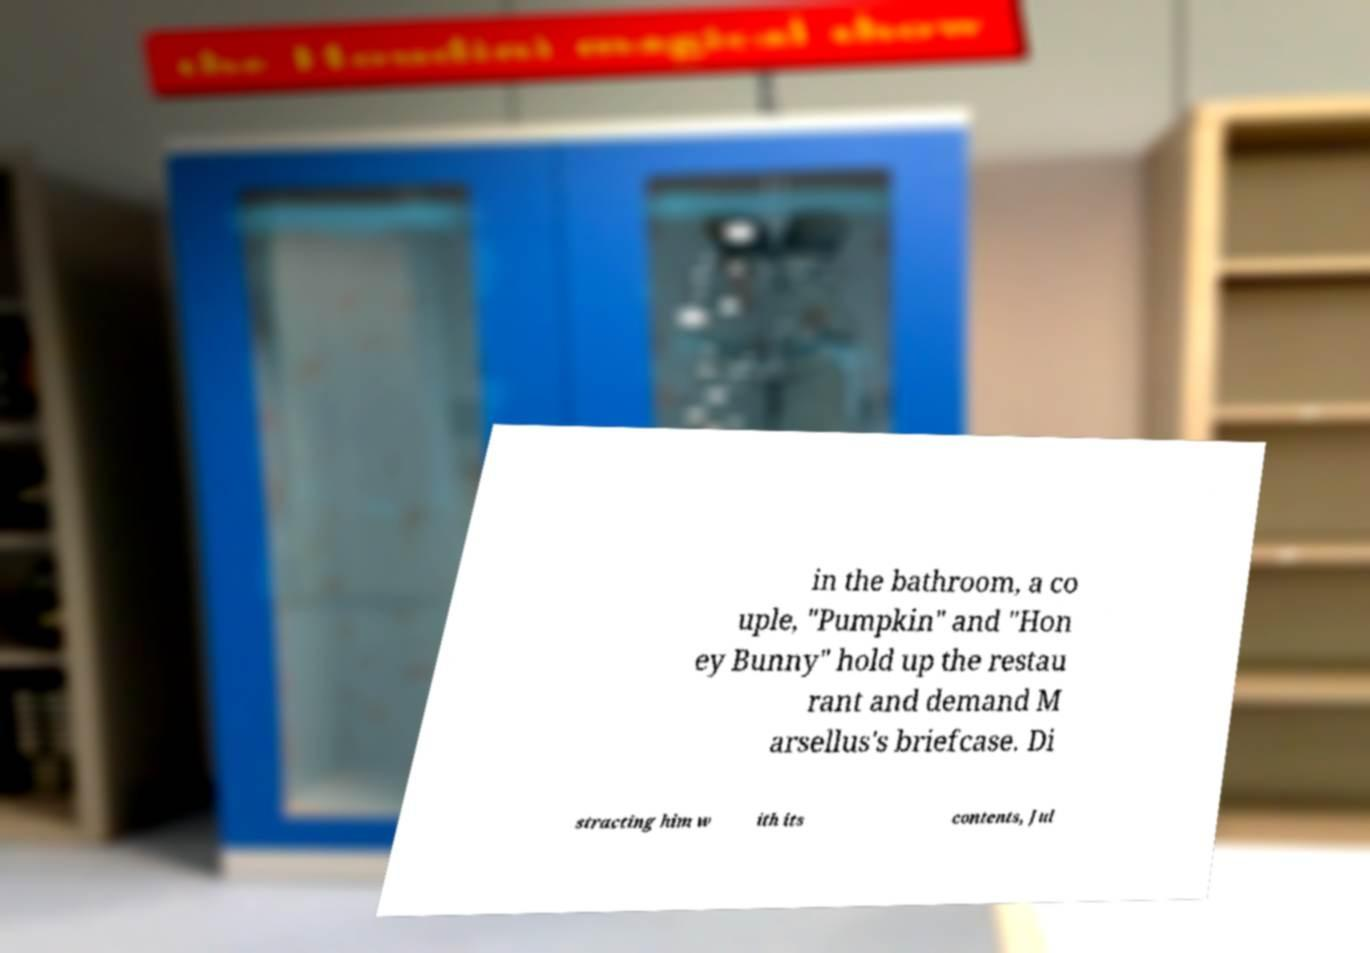There's text embedded in this image that I need extracted. Can you transcribe it verbatim? in the bathroom, a co uple, "Pumpkin" and "Hon ey Bunny" hold up the restau rant and demand M arsellus's briefcase. Di stracting him w ith its contents, Jul 